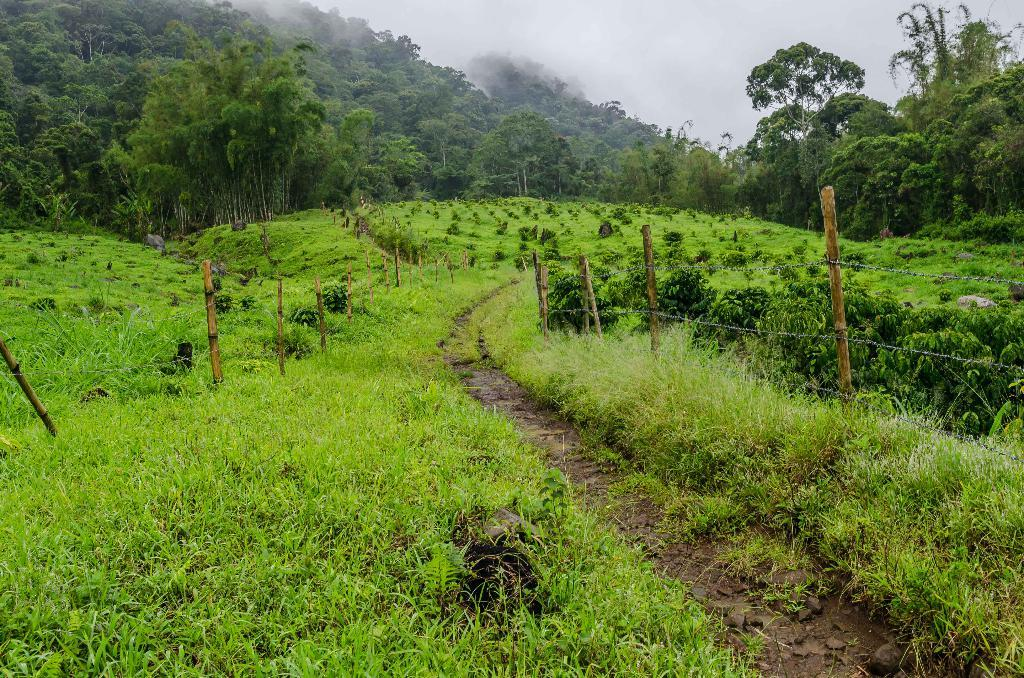What type of vegetation can be seen in the image? There are plants, trees, and grass in the image. What structures are present in the image? There are poles and fencing in the image. What part of the natural environment is visible in the image? The sky is visible in the image. What type of gate can be seen in the image? There is no gate present in the image. Who is the partner of the person in the image? There is no person in the image, so there is no partner to identify. 